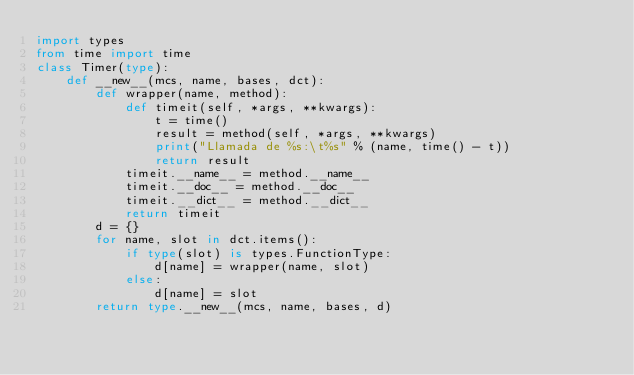Convert code to text. <code><loc_0><loc_0><loc_500><loc_500><_Python_>import types
from time import time
class Timer(type):
    def __new__(mcs, name, bases, dct):
        def wrapper(name, method):
            def timeit(self, *args, **kwargs):
                t = time()
                result = method(self, *args, **kwargs)
                print("Llamada de %s:\t%s" % (name, time() - t))
                return result
            timeit.__name__ = method.__name__
            timeit.__doc__ = method.__doc__
            timeit.__dict__ = method.__dict__
            return timeit
        d = {}
        for name, slot in dct.items():
            if type(slot) is types.FunctionType:
                d[name] = wrapper(name, slot)
            else:
                d[name] = slot
        return type.__new__(mcs, name, bases, d)

</code> 